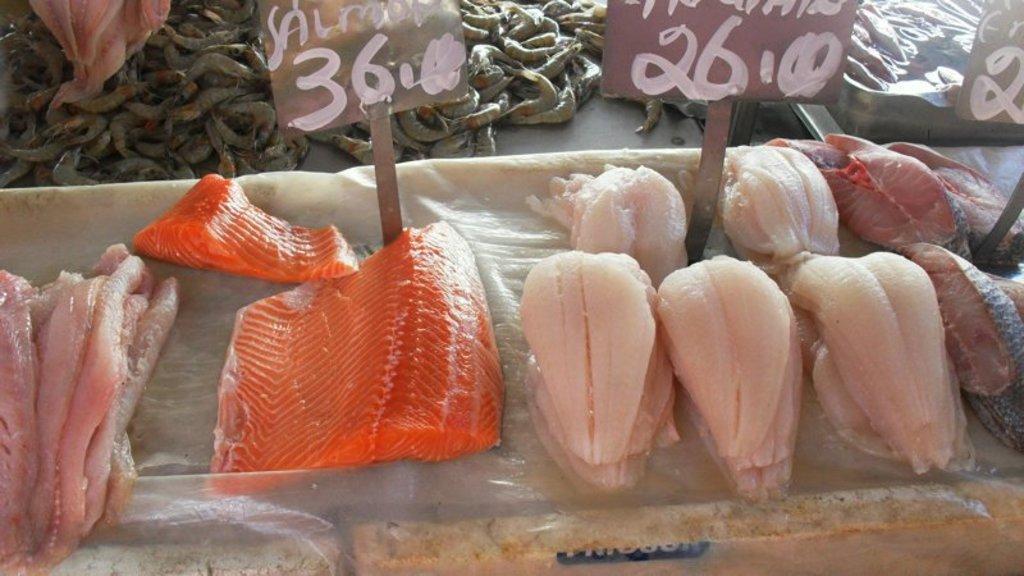Please provide a concise description of this image. In the foreground of the picture there is fish meat and name plates. At the top there are prawns. 